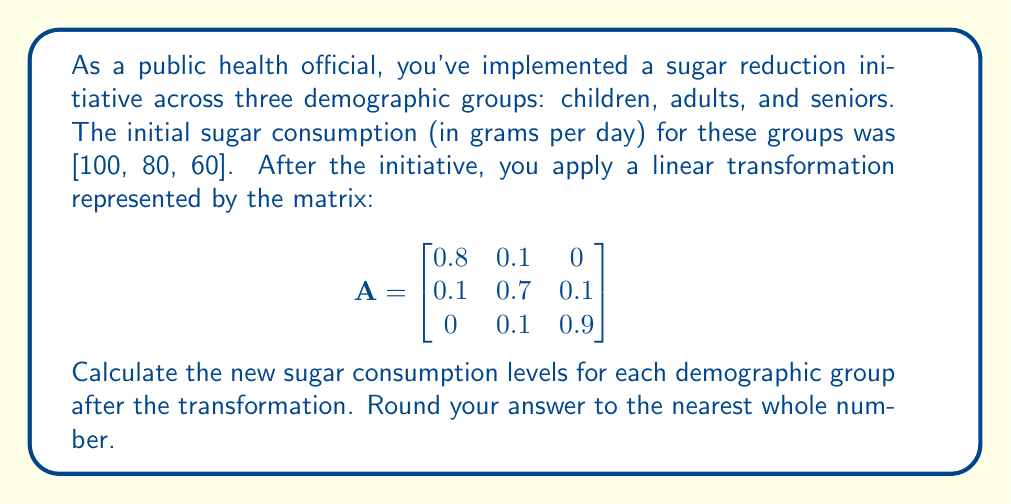Help me with this question. To solve this problem, we need to multiply the initial consumption vector by the transformation matrix. Let's break it down step-by-step:

1) First, let's set up our initial consumption vector:
   $$\vec{v} = \begin{bmatrix} 100 \\ 80 \\ 60 \end{bmatrix}$$

2) Now, we need to perform matrix multiplication: $A\vec{v}$

   $$\begin{bmatrix}
   0.8 & 0.1 & 0 \\
   0.1 & 0.7 & 0.1 \\
   0 & 0.1 & 0.9
   \end{bmatrix}
   \begin{bmatrix}
   100 \\
   80 \\
   60
   \end{bmatrix}$$

3) Let's multiply row by column:

   For children: $(0.8 \times 100) + (0.1 \times 80) + (0 \times 60) = 80 + 8 + 0 = 88$

   For adults: $(0.1 \times 100) + (0.7 \times 80) + (0.1 \times 60) = 10 + 56 + 6 = 72$

   For seniors: $(0 \times 100) + (0.1 \times 80) + (0.9 \times 60) = 0 + 8 + 54 = 62$

4) Therefore, our result vector is:
   $$\begin{bmatrix}
   88 \\
   72 \\
   62
   \end{bmatrix}$$

5) Rounding to the nearest whole number (which is already done in this case), our final answer is [88, 72, 62].
Answer: [88, 72, 62] 